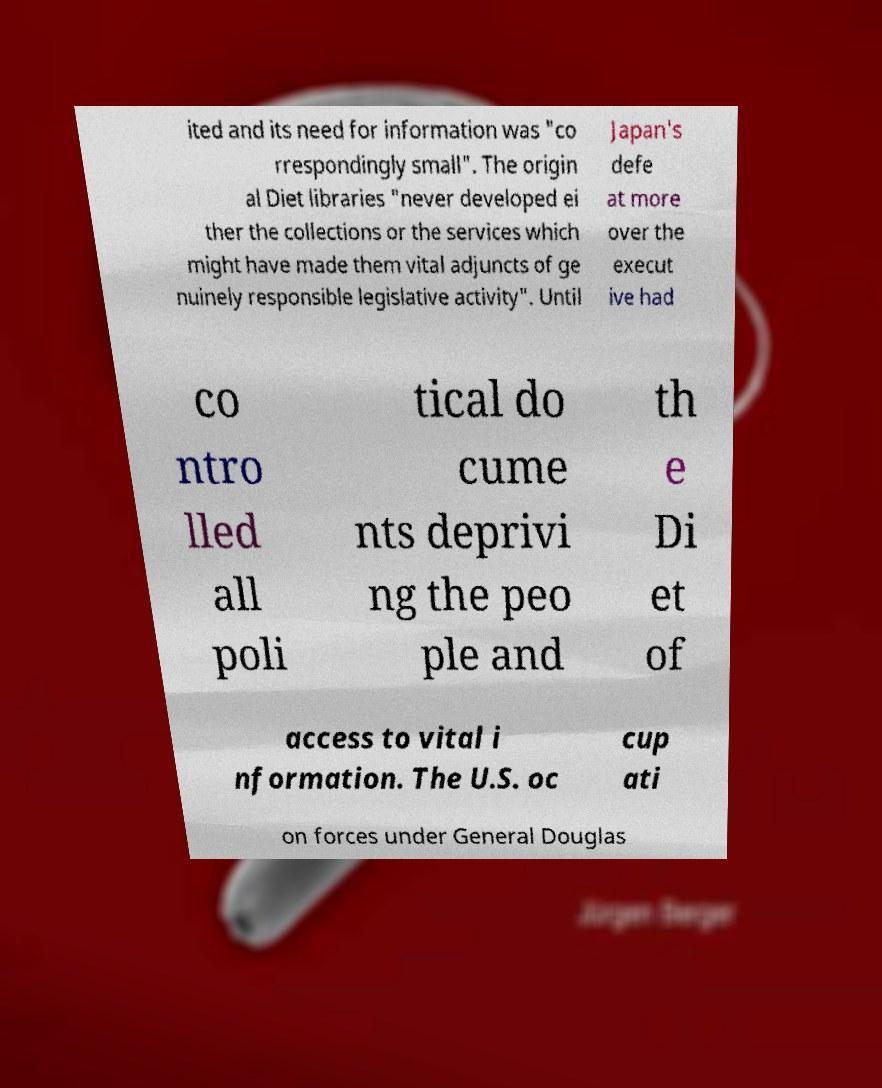Could you extract and type out the text from this image? ited and its need for information was "co rrespondingly small". The origin al Diet libraries "never developed ei ther the collections or the services which might have made them vital adjuncts of ge nuinely responsible legislative activity". Until Japan's defe at more over the execut ive had co ntro lled all poli tical do cume nts deprivi ng the peo ple and th e Di et of access to vital i nformation. The U.S. oc cup ati on forces under General Douglas 